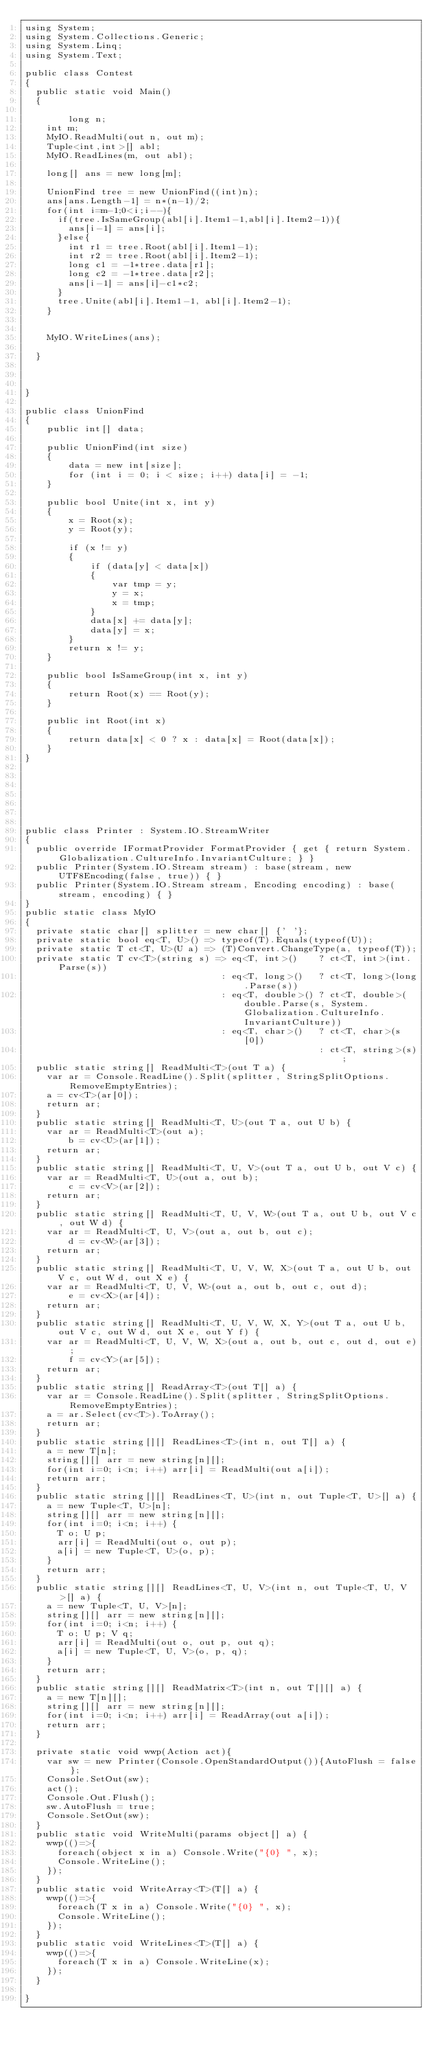<code> <loc_0><loc_0><loc_500><loc_500><_C#_>using System;
using System.Collections.Generic;
using System.Linq;
using System.Text;

public class Contest
{
	public static void Main()
	{

        long n;
		int m;
		MyIO.ReadMulti(out n, out m);
		Tuple<int,int>[] abl;
		MyIO.ReadLines(m, out abl);

		long[] ans = new long[m];
		
		UnionFind tree = new UnionFind((int)n);
		ans[ans.Length-1] = n*(n-1)/2;
		for(int i=m-1;0<i;i--){
			if(tree.IsSameGroup(abl[i].Item1-1,abl[i].Item2-1)){
				ans[i-1] = ans[i];
			}else{
				int r1 = tree.Root(abl[i].Item1-1);
				int r2 = tree.Root(abl[i].Item2-1);
				long c1 = -1*tree.data[r1];
				long c2 = -1*tree.data[r2];
				ans[i-1] = ans[i]-c1*c2;
			}
			tree.Unite(abl[i].Item1-1, abl[i].Item2-1);
		}


		MyIO.WriteLines(ans);

	}



}

public class UnionFind
{
    public int[] data;

    public UnionFind(int size)
    {
        data = new int[size];
        for (int i = 0; i < size; i++) data[i] = -1;
    }

    public bool Unite(int x, int y)
    {
        x = Root(x);
        y = Root(y);

        if (x != y)
        {
            if (data[y] < data[x])
            {
                var tmp = y;
                y = x;
                x = tmp;
            }
            data[x] += data[y];
            data[y] = x;
        }
        return x != y;
    }

    public bool IsSameGroup(int x, int y)
    {
        return Root(x) == Root(y);
    }

    public int Root(int x)
    {
        return data[x] < 0 ? x : data[x] = Root(data[x]);
    }
}







public class Printer : System.IO.StreamWriter
{
	public override IFormatProvider FormatProvider { get { return System.Globalization.CultureInfo.InvariantCulture; } }
	public Printer(System.IO.Stream stream) : base(stream, new UTF8Encoding(false, true)) { }
	public Printer(System.IO.Stream stream, Encoding encoding) : base(stream, encoding) { }
}
public static class MyIO
{
	private static char[] splitter = new char[] {' '};
	private static bool eq<T, U>() => typeof(T).Equals(typeof(U));
	private static T ct<T, U>(U a) => (T)Convert.ChangeType(a, typeof(T));
	private static T cv<T>(string s) => eq<T, int>()    ? ct<T, int>(int.Parse(s))
	                                  : eq<T, long>()   ? ct<T, long>(long.Parse(s))
	                                  : eq<T, double>() ? ct<T, double>(double.Parse(s, System.Globalization.CultureInfo.InvariantCulture))
	                                  : eq<T, char>()   ? ct<T, char>(s[0])
	                                                    : ct<T, string>(s);				
	public static string[] ReadMulti<T>(out T a) {
		var ar = Console.ReadLine().Split(splitter, StringSplitOptions.RemoveEmptyEntries); 
		a = cv<T>(ar[0]);
		return ar;
	}
	public static string[] ReadMulti<T, U>(out T a, out U b) {
		var ar = ReadMulti<T>(out a); 
        b = cv<U>(ar[1]);
		return ar;
	}
	public static string[] ReadMulti<T, U, V>(out T a, out U b, out V c) {
		var ar = ReadMulti<T, U>(out a, out b); 
        c = cv<V>(ar[2]);
		return ar;
	}
	public static string[] ReadMulti<T, U, V, W>(out T a, out U b, out V c, out W d) {
		var ar = ReadMulti<T, U, V>(out a, out b, out c); 
        d = cv<W>(ar[3]);
		return ar;
	}
	public static string[] ReadMulti<T, U, V, W, X>(out T a, out U b, out V c, out W d, out X e) {
		var ar = ReadMulti<T, U, V, W>(out a, out b, out c, out d); 
        e = cv<X>(ar[4]);
		return ar;
	}
	public static string[] ReadMulti<T, U, V, W, X, Y>(out T a, out U b, out V c, out W d, out X e, out Y f) {
		var ar = ReadMulti<T, U, V, W, X>(out a, out b, out c, out d, out e); 
        f = cv<Y>(ar[5]);
		return ar;
	}
	public static string[] ReadArray<T>(out T[] a) {		
		var ar = Console.ReadLine().Split(splitter, StringSplitOptions.RemoveEmptyEntries);
		a = ar.Select(cv<T>).ToArray();
		return ar;
	}		
	public static string[][] ReadLines<T>(int n, out T[] a) {
		a = new T[n];
		string[][] arr = new string[n][];
		for(int i=0; i<n; i++) arr[i] = ReadMulti(out a[i]);
		return arr;
	}
	public static string[][] ReadLines<T, U>(int n, out Tuple<T, U>[] a) {
		a = new Tuple<T, U>[n];
		string[][] arr = new string[n][];
		for(int i=0; i<n; i++) {
			T o; U p;
			arr[i] = ReadMulti(out o, out p);
			a[i] = new Tuple<T, U>(o, p);
		}
		return arr;
	}
	public static string[][] ReadLines<T, U, V>(int n, out Tuple<T, U, V>[] a) {
		a = new Tuple<T, U, V>[n];
		string[][] arr = new string[n][];
		for(int i=0; i<n; i++) {
			T o; U p; V q;
			arr[i] = ReadMulti(out o, out p, out q);
			a[i] = new Tuple<T, U, V>(o, p, q);
		}
		return arr;
	}
	public static string[][] ReadMatrix<T>(int n, out T[][] a) {
		a = new T[n][];
		string[][] arr = new string[n][];
		for(int i=0; i<n; i++) arr[i] = ReadArray(out a[i]);
		return arr;
	}

	private static void wwp(Action act){
		var sw = new Printer(Console.OpenStandardOutput()){AutoFlush = false};
		Console.SetOut(sw);
		act();
		Console.Out.Flush();
		sw.AutoFlush = true;
		Console.SetOut(sw);
	}
	public static void WriteMulti(params object[] a) {
		wwp(()=>{
			foreach(object x in a) Console.Write("{0} ", x);
			Console.WriteLine();
		});
	}
	public static void WriteArray<T>(T[] a) {
		wwp(()=>{
			foreach(T x in a) Console.Write("{0} ", x);
			Console.WriteLine();
		});
	}
	public static void WriteLines<T>(T[] a) {
		wwp(()=>{
			foreach(T x in a) Console.WriteLine(x);
		});
	}

}



</code> 